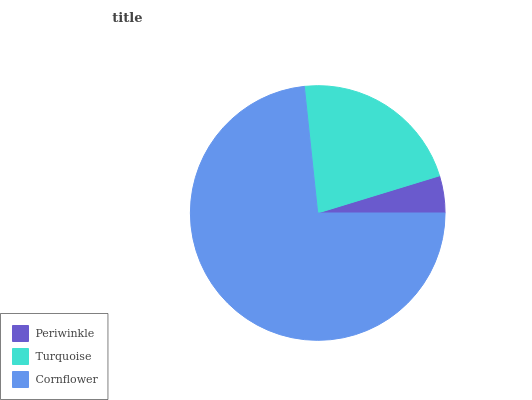Is Periwinkle the minimum?
Answer yes or no. Yes. Is Cornflower the maximum?
Answer yes or no. Yes. Is Turquoise the minimum?
Answer yes or no. No. Is Turquoise the maximum?
Answer yes or no. No. Is Turquoise greater than Periwinkle?
Answer yes or no. Yes. Is Periwinkle less than Turquoise?
Answer yes or no. Yes. Is Periwinkle greater than Turquoise?
Answer yes or no. No. Is Turquoise less than Periwinkle?
Answer yes or no. No. Is Turquoise the high median?
Answer yes or no. Yes. Is Turquoise the low median?
Answer yes or no. Yes. Is Periwinkle the high median?
Answer yes or no. No. Is Cornflower the low median?
Answer yes or no. No. 